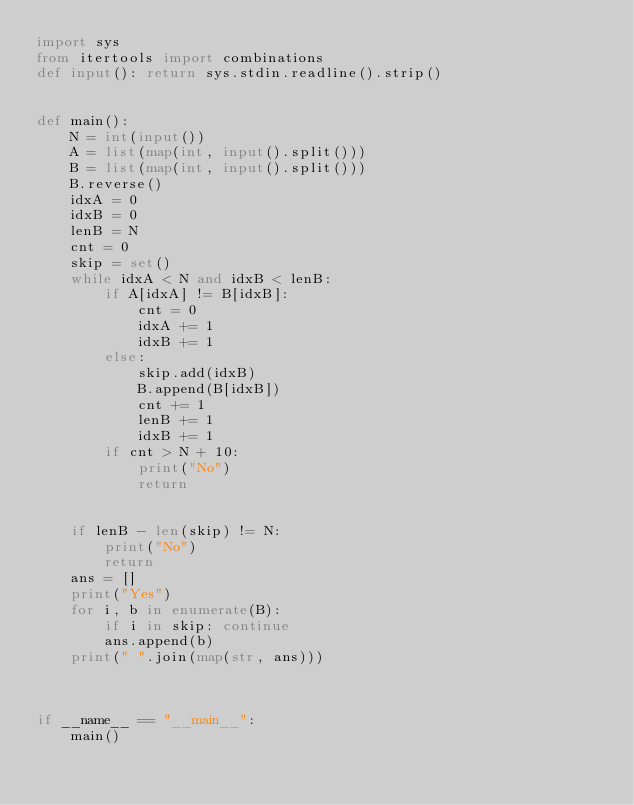Convert code to text. <code><loc_0><loc_0><loc_500><loc_500><_Python_>import sys
from itertools import combinations
def input(): return sys.stdin.readline().strip()


def main():
    N = int(input())
    A = list(map(int, input().split()))
    B = list(map(int, input().split()))
    B.reverse()
    idxA = 0
    idxB = 0
    lenB = N
    cnt = 0
    skip = set()
    while idxA < N and idxB < lenB:
        if A[idxA] != B[idxB]:
            cnt = 0
            idxA += 1
            idxB += 1
        else:
            skip.add(idxB)
            B.append(B[idxB])
            cnt += 1
            lenB += 1
            idxB += 1
        if cnt > N + 10:
            print("No")
            return


    if lenB - len(skip) != N:
        print("No")
        return
    ans = []
    print("Yes")
    for i, b in enumerate(B):
        if i in skip: continue
        ans.append(b)
    print(" ".join(map(str, ans)))



if __name__ == "__main__":
    main()
</code> 